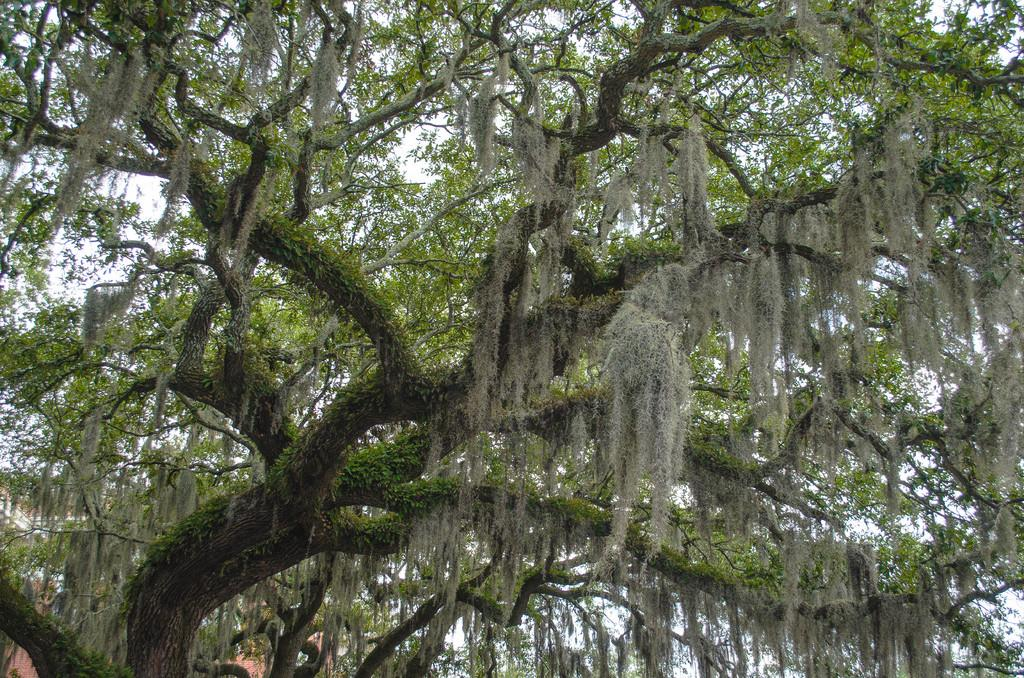What is the main feature of the picture? There is a big tree in the picture. What can be seen in the background of the picture? The sky is visible in the picture. Where is the crib located in the picture? There is no crib present in the picture; it only features a big tree and the sky. What type of activity is happening in the picture? The picture does not depict any specific activity; it simply shows a big tree and the sky. 